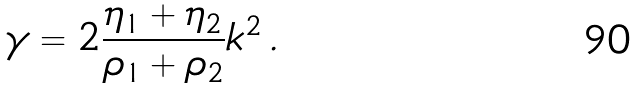Convert formula to latex. <formula><loc_0><loc_0><loc_500><loc_500>\gamma = 2 \frac { \eta _ { 1 } + \eta _ { 2 } } { \rho _ { 1 } + \rho _ { 2 } } k ^ { 2 } \, .</formula> 